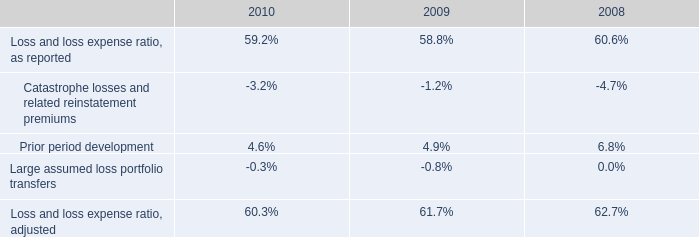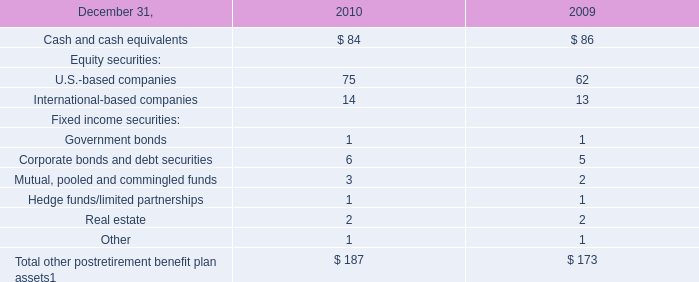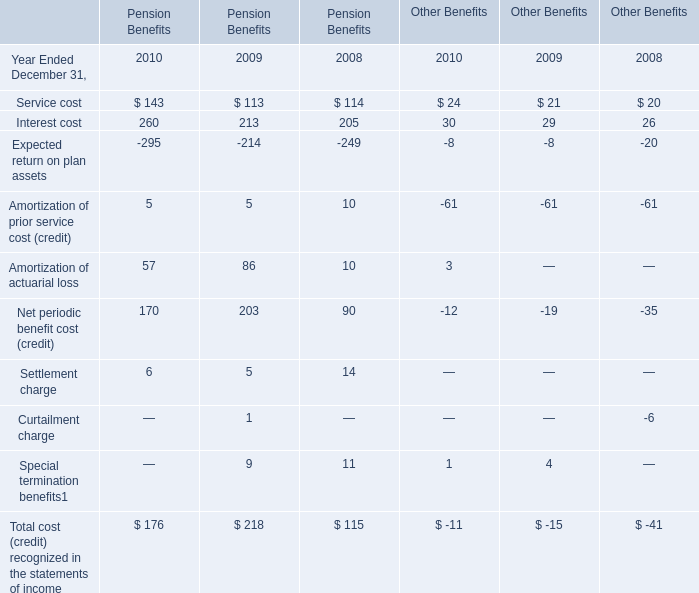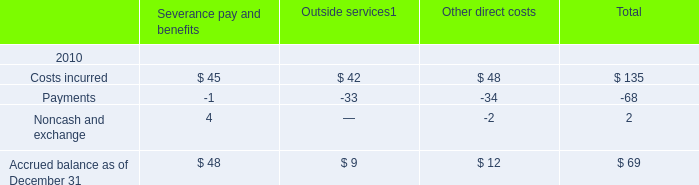What was the average of Interest cost for Pension Benefits in 2010, 2009, and 2008? 
Computations: (((260 + 213) + 205) / 3)
Answer: 226.0. 